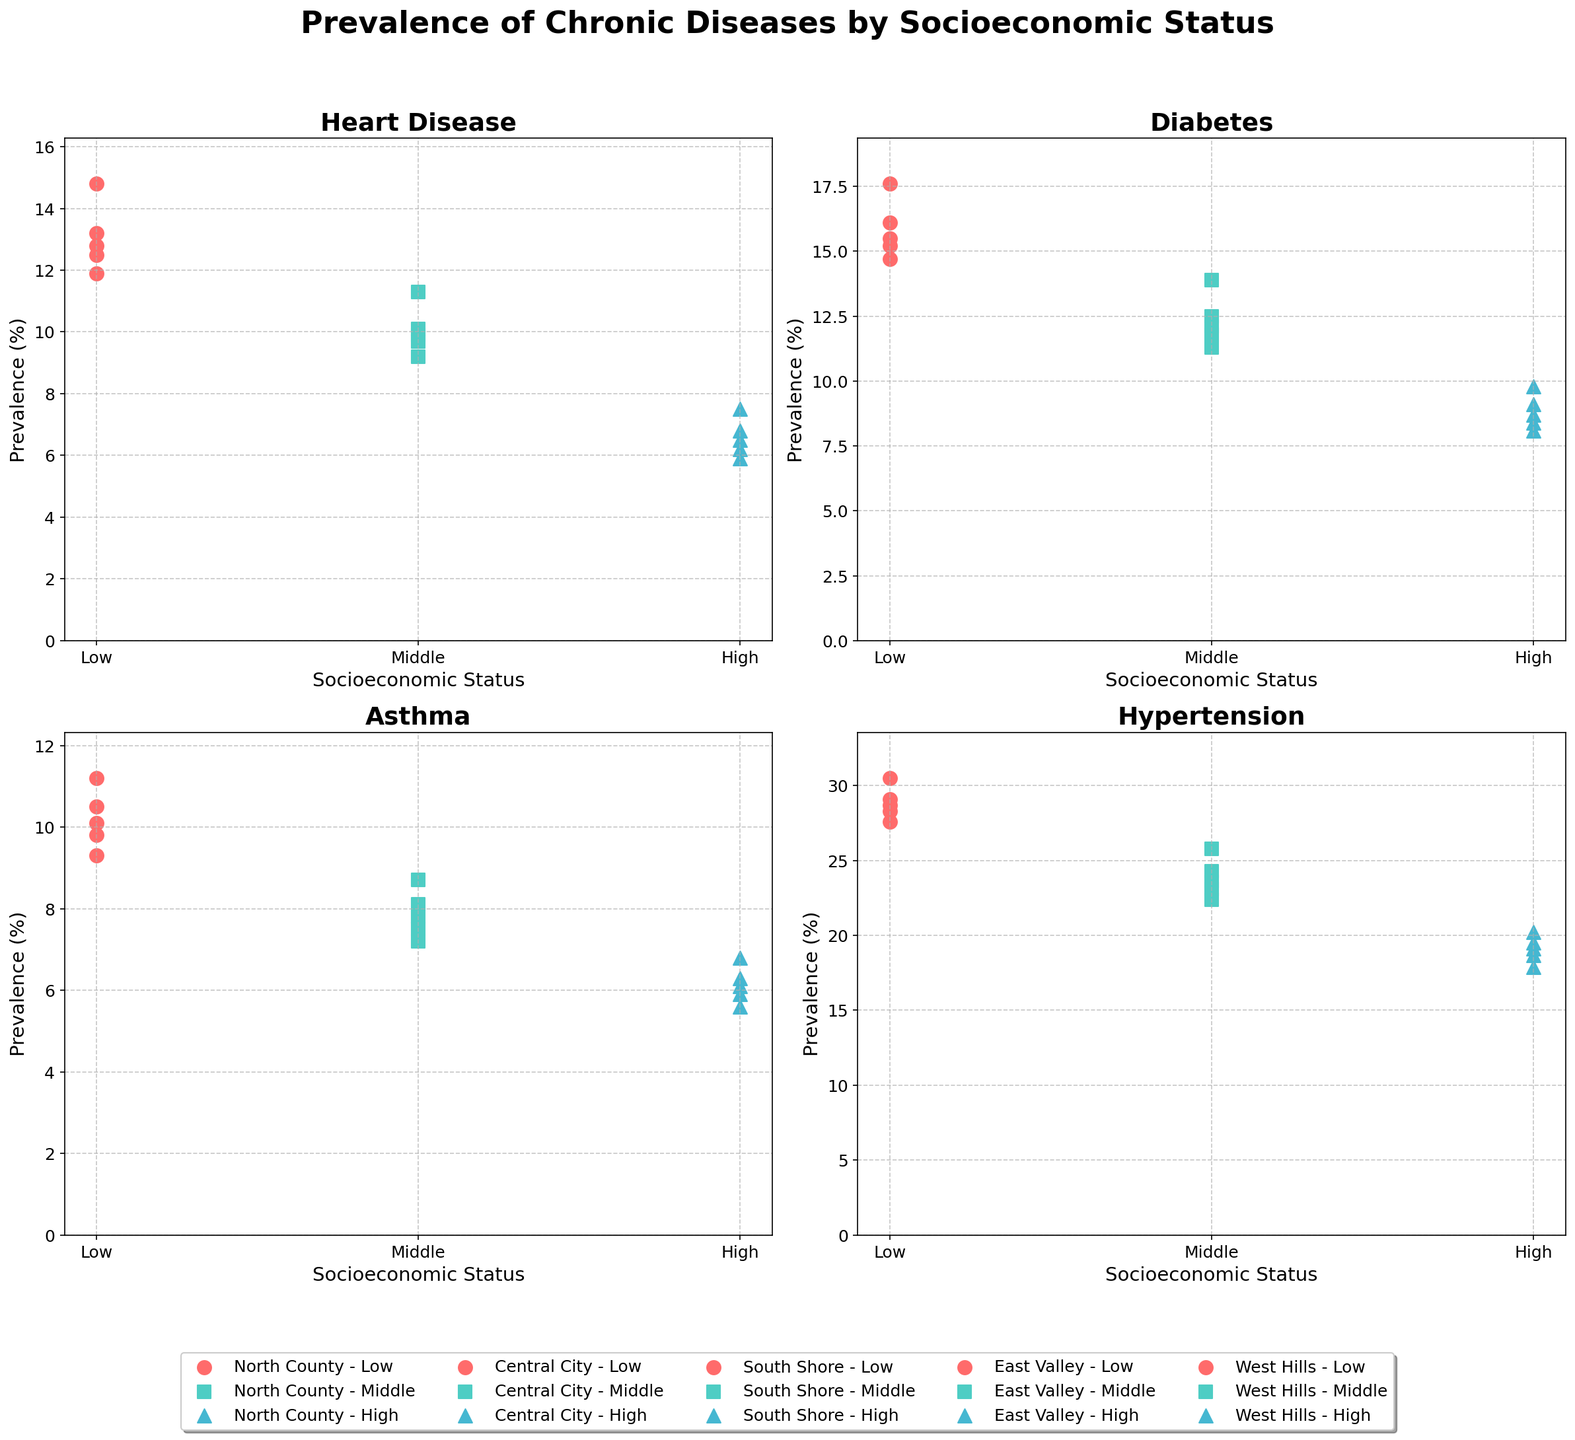What is the prevalence of Heart Disease in Central City for the Low SES group? Look at the subplot for Heart Disease. Identify the point for Central City with Low SES and note down its prevalence.
Answer: 14.8% Which district has the highest prevalence of Diabetes among the High SES group? Compare the prevalence of Diabetes across all districts for the High SES group. Central City has the highest value among them.
Answer: Central City Is the prevalence of Asthma higher in North County for the Low SES group or in West Hills for the Low SES group? Check the subplot for Asthma. Compare the values for North County (Low SES) and West Hills (Low SES).
Answer: West Hills What is the difference in prevalence of Hypertension between Low and High SES groups in South Shore? Look at the Hypertension subplot. Note the values for South Shore in Low and High SES groups. Subtract the High SES value from the Low SES value.
Answer: 9.6% What is the average prevalence of Heart Disease across all SES levels in East Valley? Look at the Heart Disease subplot. Note the values for East Valley under Low, Middle, and High SES. (11.9 + 9.2 + 5.9) / 3 = 9.0
Answer: 9.0% Compare the prevalence of Diabetes between Low SES of Central City and High SES of East Valley. Which one is higher? Identify the Diabetes values for Central City (Low SES) and East Valley (High SES). Compare them.
Answer: Central City Which SES level has the smallest prevalence of Asthma in North County? Check the Asthma subplot. Identify the prevalence values for North County across all SES levels and find the smallest.
Answer: High In which district and SES group is the prevalence of Hypertension closest to 25%? Examine the Hypertension subplot and identify which point is closest to 25% across all district and SES combinations.
Answer: Central City, Middle What is the combined prevalence of Heart Disease and Hypertension in West Hills for the Middle SES group? Find the values for Heart Disease and Hypertension in West Hills for the Middle SES. Add them together. 9.9 + 23.6 = 33.5
Answer: 33.5% How does the prevalence of Diabetes in North County for the Middle SES group compare to the prevalence of Asthma in South Shore for the Middle SES group? Compare the values for North County (Middle SES) Diabetes and South Shore (Middle SES) Asthma.
Answer: North County is higher 